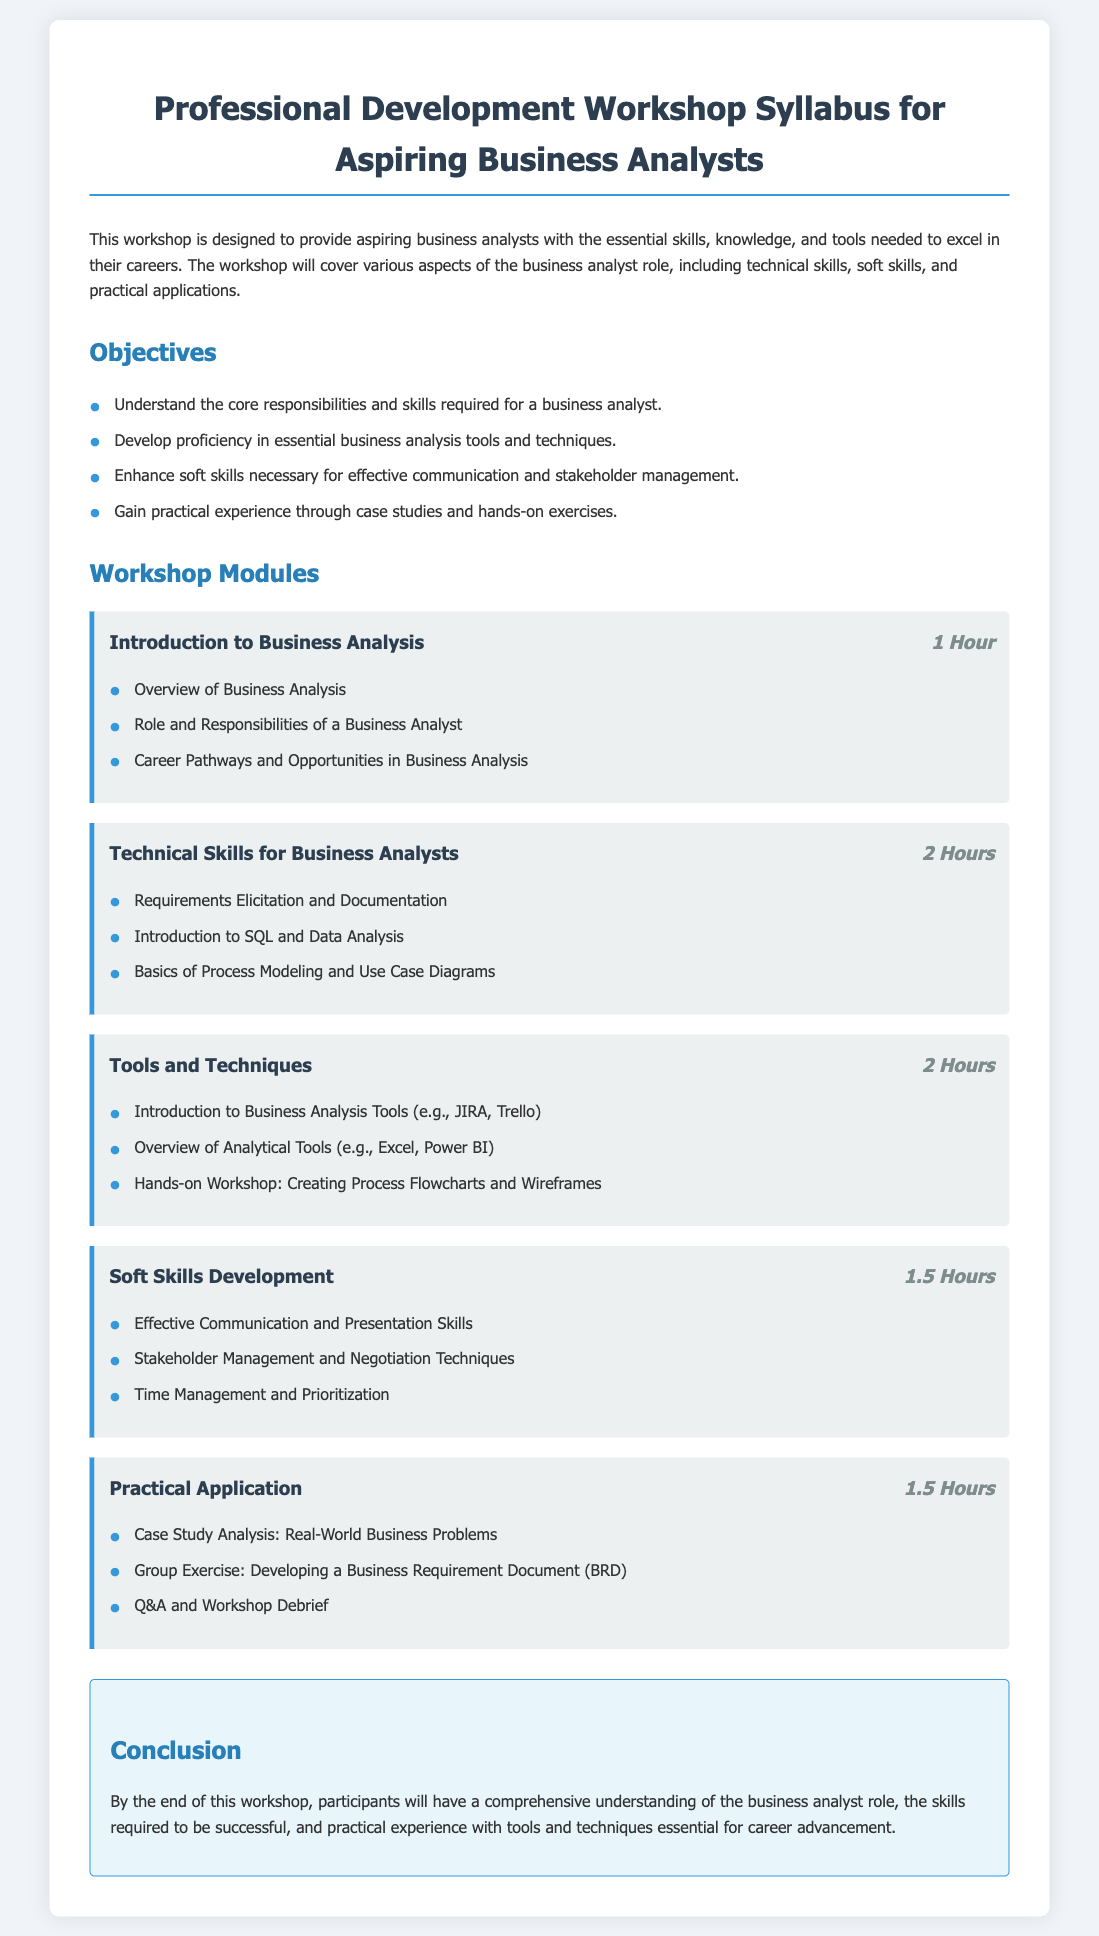what is the title of the document? The title summarizes the content and intent of the document, which is to provide a syllabus for a specific workshop.
Answer: Professional Development Workshop Syllabus for Aspiring Business Analysts how many hours is the module "Technical Skills for Business Analysts"? The duration of this module is explicitly stated in the document.
Answer: 2 Hours what is one tool mentioned in the "Tools and Techniques" module? This question asks for a specific example of a tool from the listed content under that module.
Answer: JIRA what is one of the objectives of the workshop? The objectives are listed in a clear format, allowing for easy retrieval of information.
Answer: Understand the core responsibilities and skills required for a business analyst which soft skill is developed in the "Soft Skills Development" module? This question targets the specific skills addressed in that module.
Answer: Effective Communication and Presentation Skills how long is the "Practical Application" module? The duration of this module is specifically mentioned in the document.
Answer: 1.5 Hours what type of exercise is included in the "Practical Application" module? This question seeks to identify the nature of activities included in that module based on the document.
Answer: Group Exercise how many total hours are focused on soft skills development? The total hours of the soft skills module need to be summed for accurate measurement.
Answer: 1.5 Hours what is the main purpose of the workshop? This question targets the overarching goal described at the beginning of the document.
Answer: Provide aspiring business analysts with the essential skills, knowledge, and tools needed to excel in their careers 